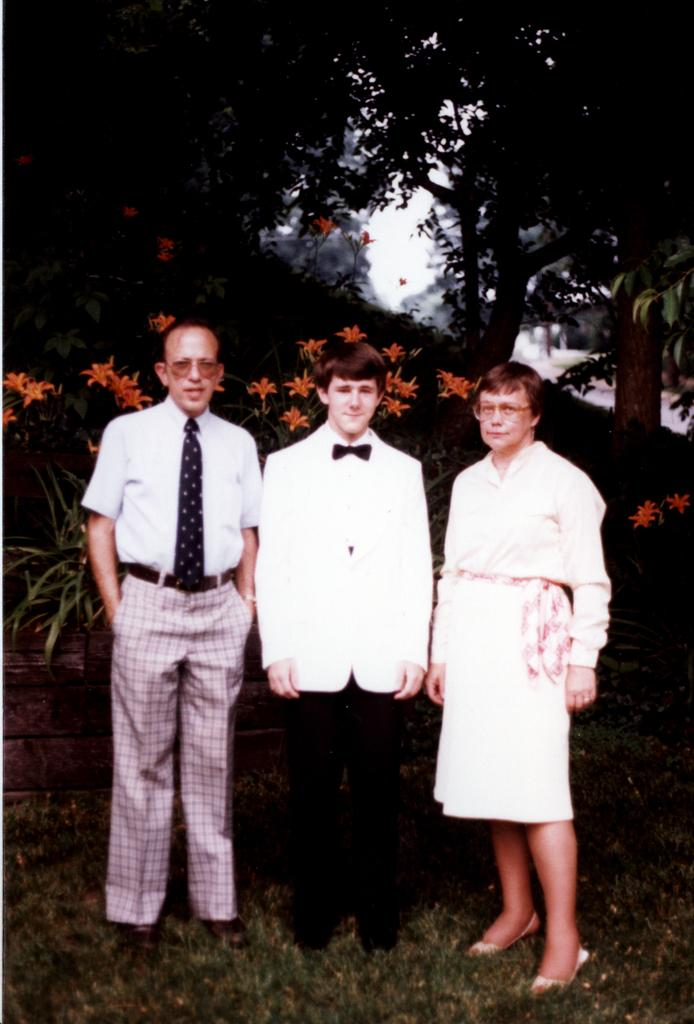How many people are in the image? There are three persons in the image. What are the persons wearing? The persons are wearing white dresses. What are the persons doing in the image? The persons are standing. What type of ground is visible at the bottom of the image? There is grass at the bottom of the image. What can be seen in the background of the image? There are plants and trees in the background of the image. What type of business is being conducted in the image? There is no indication of any business being conducted in the image; it features three persons wearing white dresses and standing on grass with plants and trees in the background. What type of vessel is visible in the image? There is no vessel present in the image. 